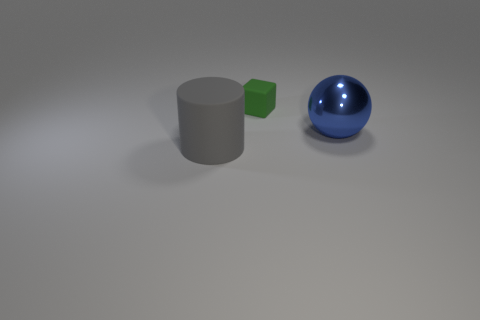Add 2 large blue shiny objects. How many objects exist? 5 Subtract all cylinders. How many objects are left? 2 Subtract 1 cylinders. How many cylinders are left? 0 Subtract all red cylinders. How many purple balls are left? 0 Subtract all blue rubber objects. Subtract all large blue things. How many objects are left? 2 Add 1 tiny rubber objects. How many tiny rubber objects are left? 2 Add 3 large brown metallic cubes. How many large brown metallic cubes exist? 3 Subtract 0 purple blocks. How many objects are left? 3 Subtract all cyan balls. Subtract all yellow cubes. How many balls are left? 1 